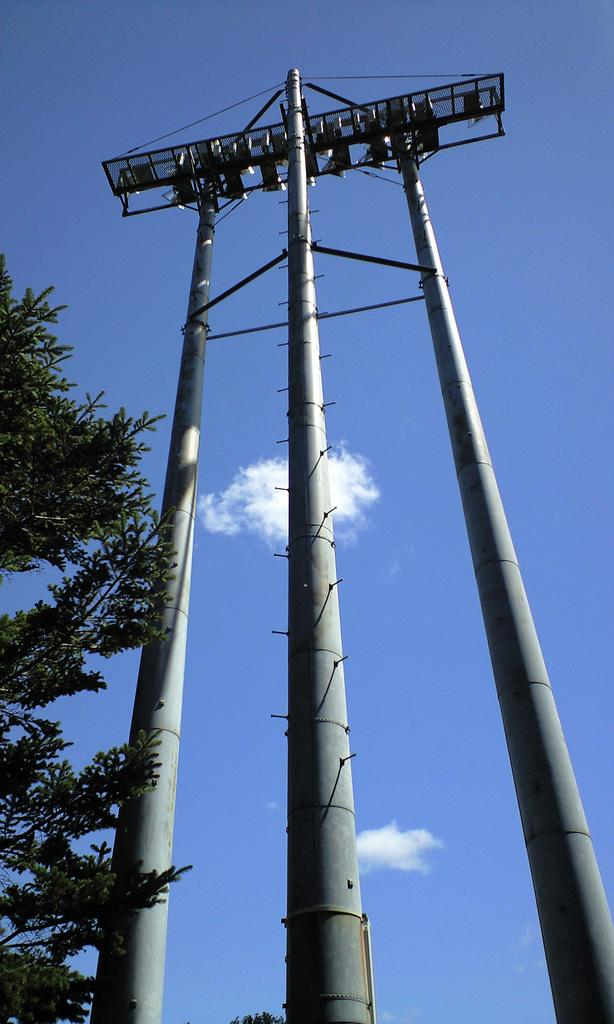What structures are present in the image? There are towers in the image. What type of vegetation can be seen in the image? There are trees in the image. What is visible in the sky in the image? There are clouds in the image. Can you see a plane flying through the clouds in the image? There is no plane visible in the image; only towers, trees, and clouds are present. Are there any beetles crawling on the trees in the image? There is no indication of beetles or any other insects on the trees in the image. 